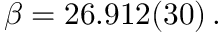<formula> <loc_0><loc_0><loc_500><loc_500>\beta = 2 6 . 9 1 2 ( 3 0 ) \, .</formula> 